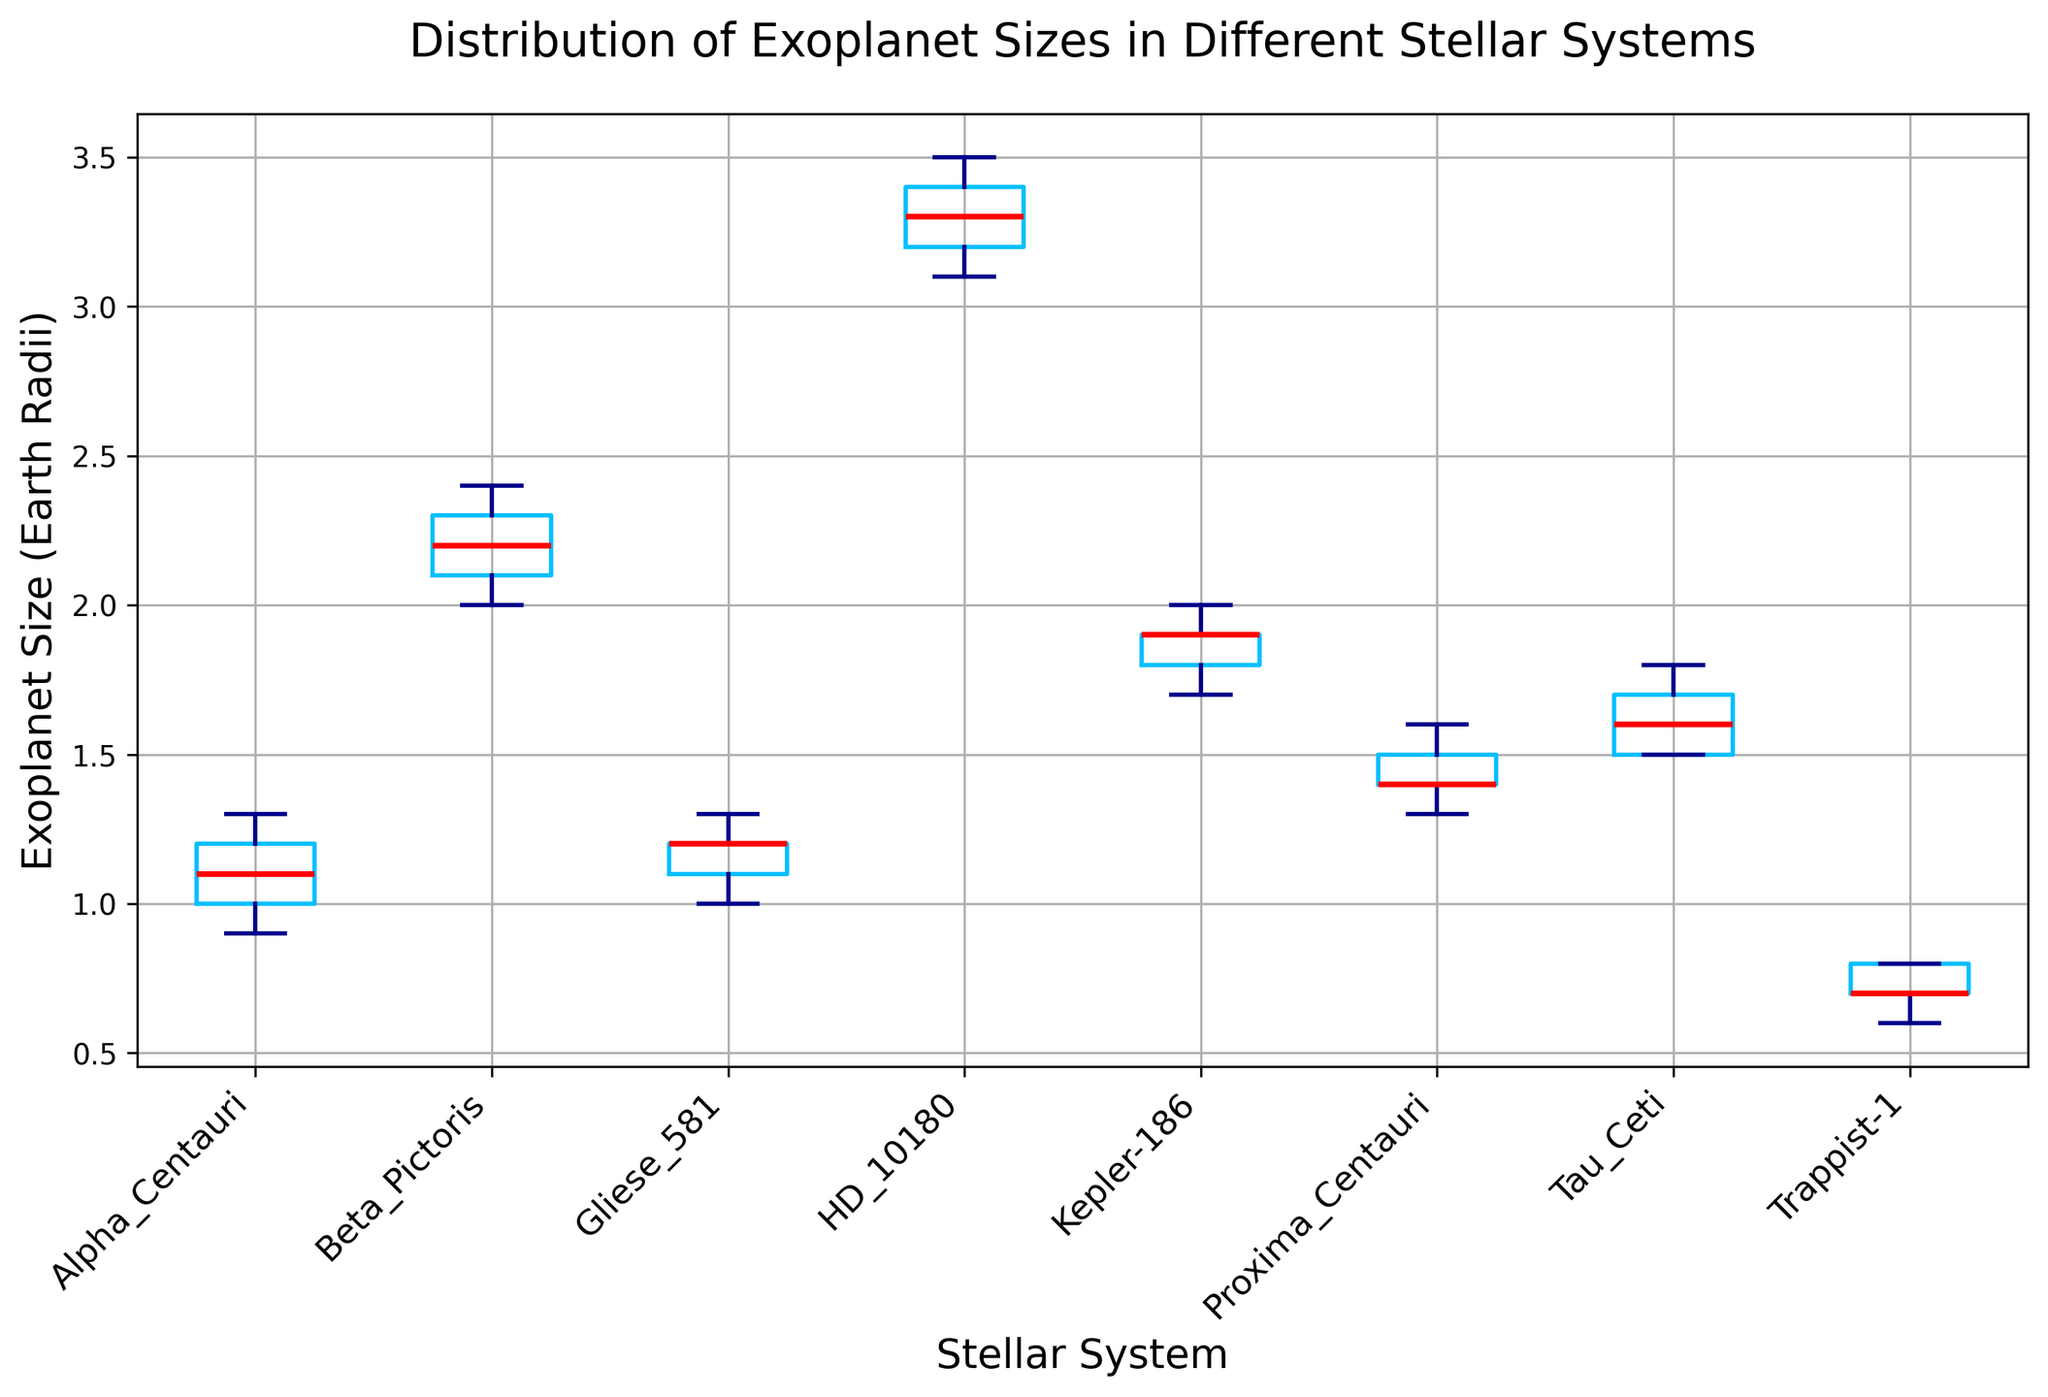What's the median exoplanet size in the Alpha Centauri system? To find the median, we arrange the sizes in ascending order: [0.9, 1.0, 1.1, 1.2, 1.3]. The median is the middle value, which is 1.1.
Answer: 1.1 Which stellar system has the largest median exoplanet size? By examining the box plots, HD 10180 has the largest median, which is marked by the red line in the box plot situated at 3.3.
Answer: HD 10180 Which stellar system has the smallest range of exoplanet sizes? The range is the difference between the maximum and minimum values. Visually comparing the length of the whiskers, Trappist-1 seems to have the smallest range (0.8 - 0.6 = 0.2).
Answer: Trappist-1 What is the interquartile range (IQR) of the exoplanet sizes in Beta Pictoris? The IQR is the difference between the third (Q3) and first quartile (Q1) values. Visually, Q3 is around 2.3 and Q1 is around 2.1, making the IQR approximately 2.3 - 2.1 = 0.2.
Answer: 0.2 Which stellar system has the highest variability in exoplanet sizes? Variability can be seen from the length of the whiskers and the spread of the boxes. HD 10180 shows the highest variability as both the box and whiskers are the longest.
Answer: HD 10180 Are there any outliers in the Trappist-1 system? Outliers are represented by points outside the whiskers. In the Trappist-1 system, there are no points outside the whiskers, so there are no outliers.
Answer: No How do the median exoplanet sizes of Kepler-186 and Beta Pictoris compare? The median sizes can be compared by the position of the red lines in each box plot. Both Kepler-186 and Beta Pictoris have their medians around 2.1.
Answer: Equal Which stellar system has a median exoplanet size closest to the median size of Tau Ceti? The median of Tau Ceti is about 1.6. Proxima Centauri also has a median around 1.5, which is the closest compared to other systems.
Answer: Proxima Centauri 